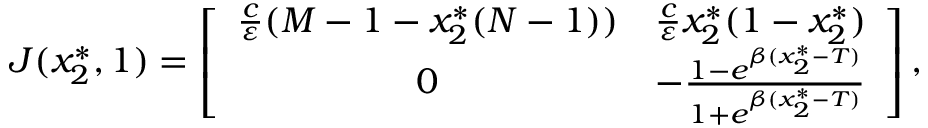<formula> <loc_0><loc_0><loc_500><loc_500>\begin{array} { r } { J ( x _ { 2 } ^ { * } , 1 ) = \left [ { \begin{array} { c c } { \frac { c } { \varepsilon } ( M - 1 - x _ { 2 } ^ { * } ( N - 1 ) ) } & { \frac { c } { \varepsilon } x _ { 2 } ^ { * } ( 1 - x _ { 2 } ^ { * } ) } \\ { 0 } & { - \frac { 1 - e ^ { \beta ( x _ { 2 } ^ { * } - T ) } } { 1 + e ^ { \beta ( x _ { 2 } ^ { * } - T ) } } } \end{array} } \right ] , } \end{array}</formula> 